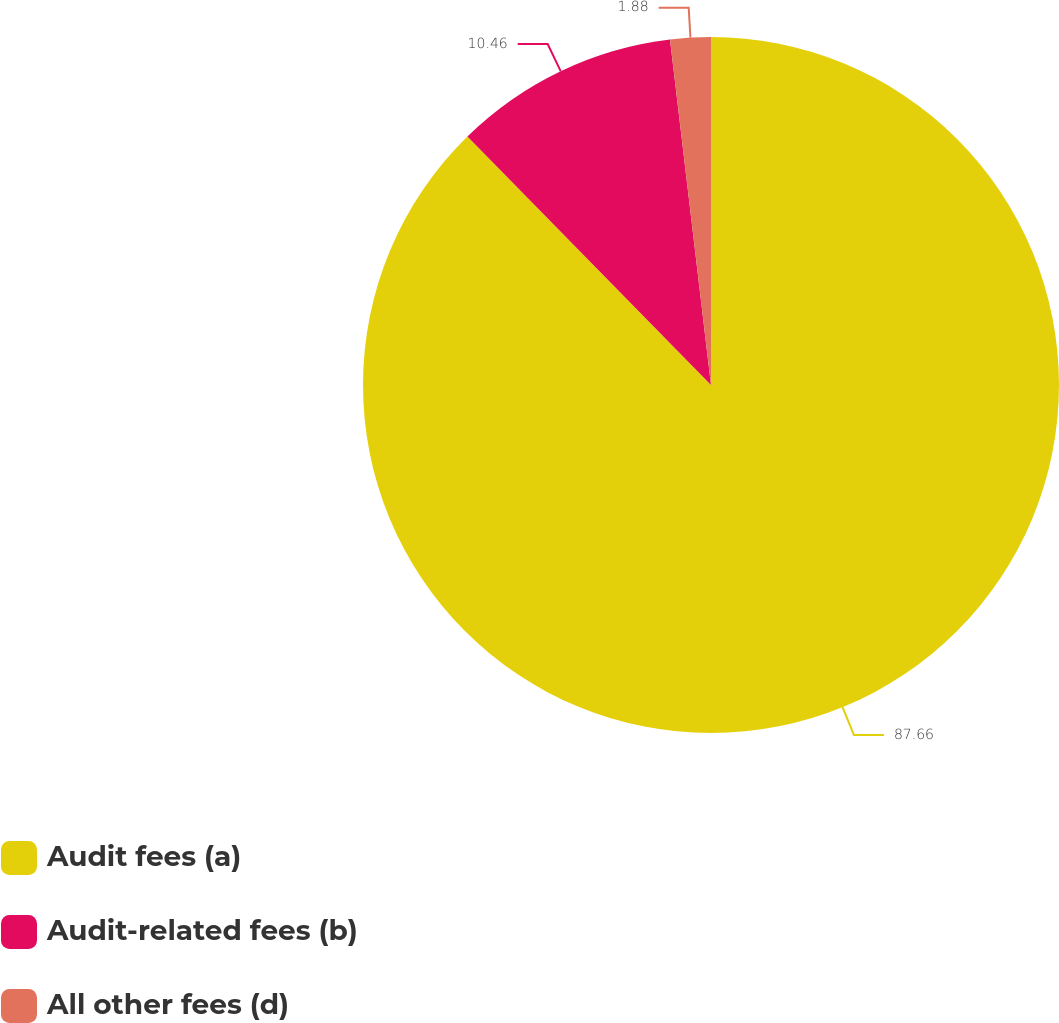Convert chart to OTSL. <chart><loc_0><loc_0><loc_500><loc_500><pie_chart><fcel>Audit fees (a)<fcel>Audit-related fees (b)<fcel>All other fees (d)<nl><fcel>87.66%<fcel>10.46%<fcel>1.88%<nl></chart> 